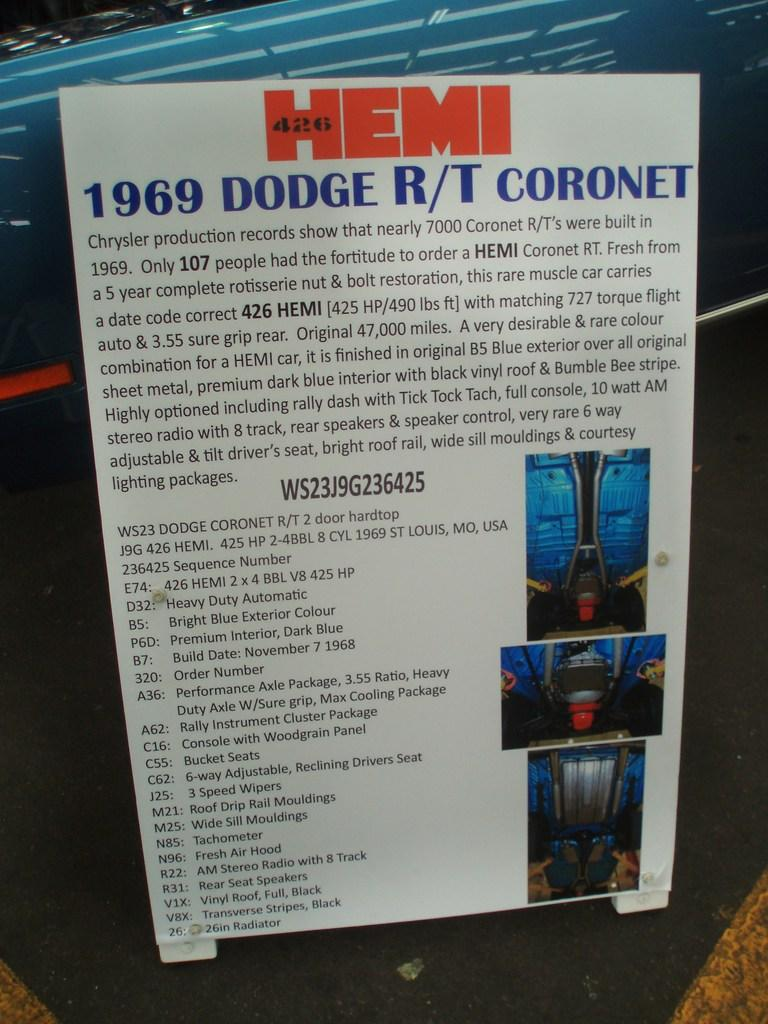<image>
Relay a brief, clear account of the picture shown. Sign that says 1969 Dodge RT coronet placed outdoors on a stret. 